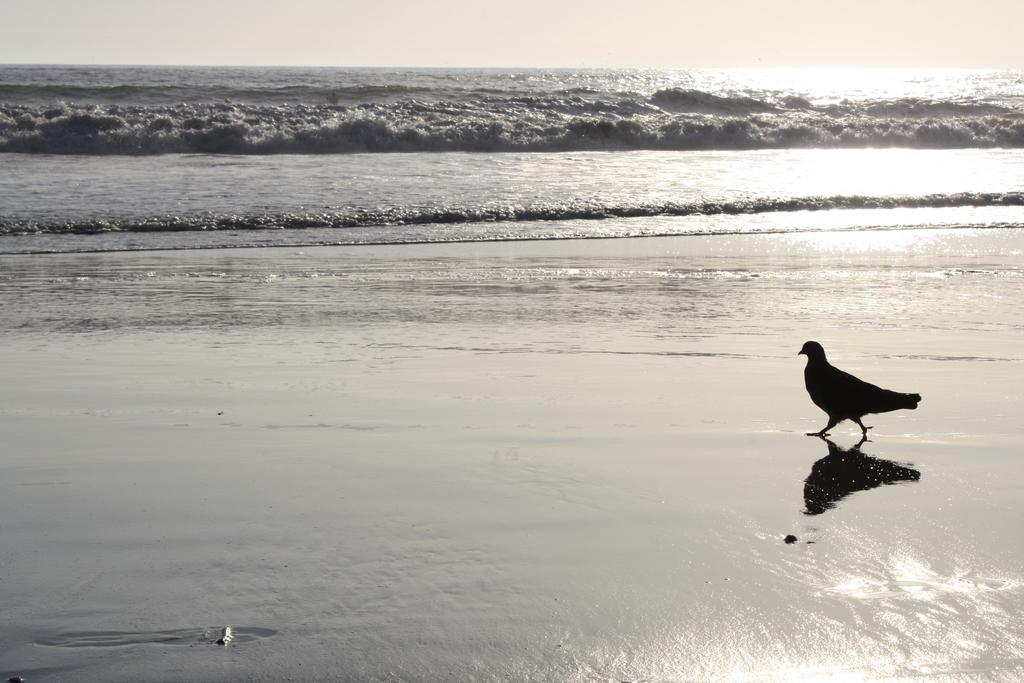What type of animal can be seen in the image? There is a bird in the image. What can be seen in the background of the image? There is water visible in the background of the image. What type of calendar is hanging from the bird's beak in the image? There is no calendar present in the image, and the bird's beak is not holding anything. 